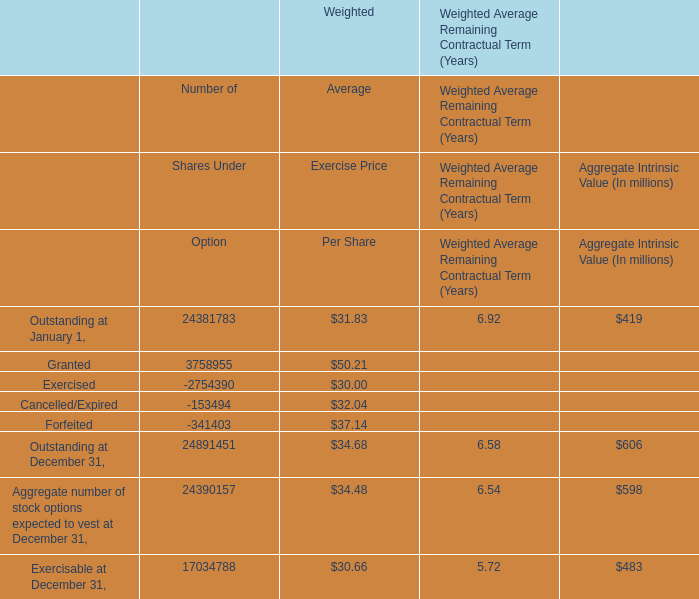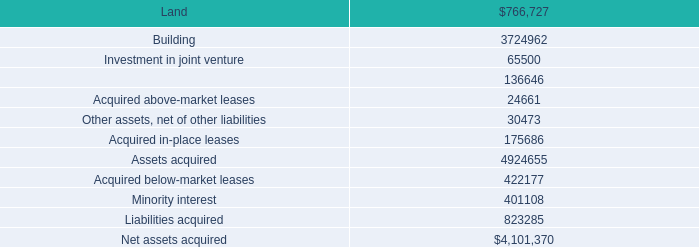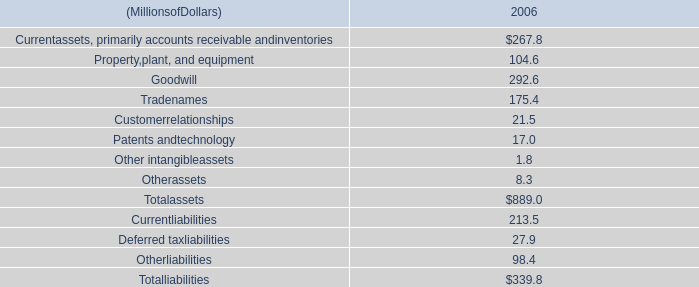for the reckson deal , was was the average cost per square foot for the properties acquired? 
Computations: ((9 * 1000) / 9.2)
Answer: 978.26087. 